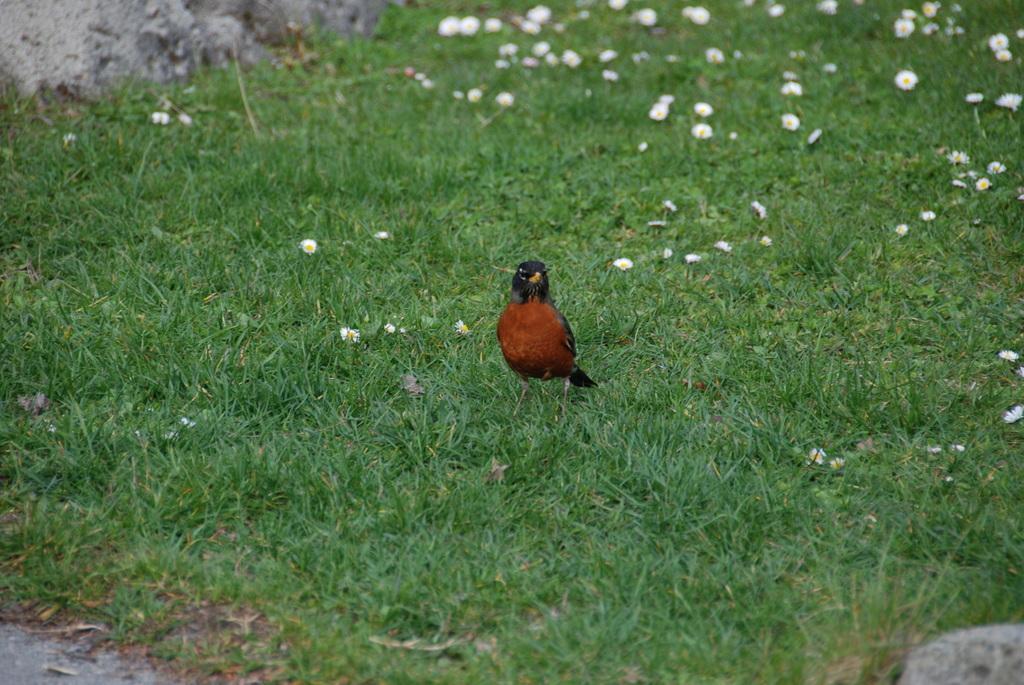How would you summarize this image in a sentence or two? In the center of the image there is a bird on the grass. 